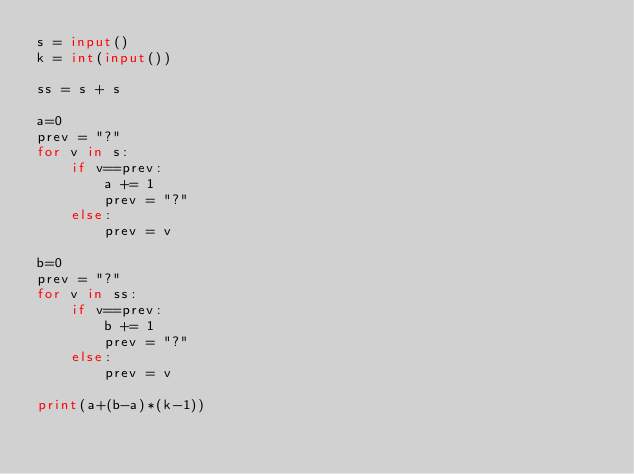<code> <loc_0><loc_0><loc_500><loc_500><_Python_>s = input()
k = int(input())

ss = s + s

a=0
prev = "?"
for v in s:
    if v==prev:
        a += 1
        prev = "?"
    else:
        prev = v
    
b=0
prev = "?"
for v in ss:
    if v==prev:
        b += 1
        prev = "?"
    else:
        prev = v

print(a+(b-a)*(k-1))</code> 